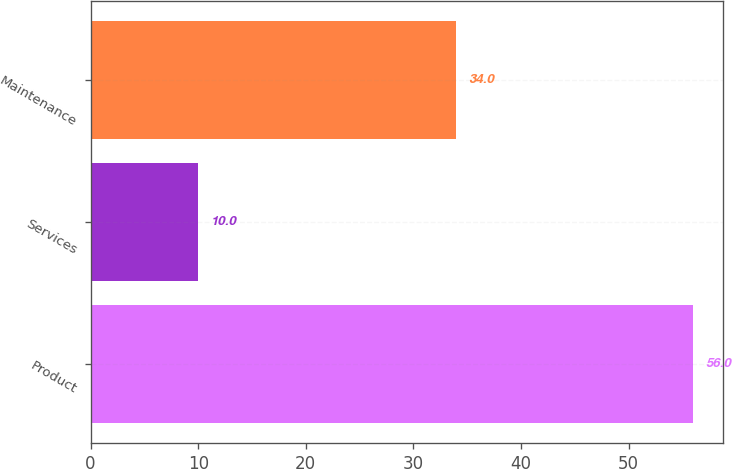<chart> <loc_0><loc_0><loc_500><loc_500><bar_chart><fcel>Product<fcel>Services<fcel>Maintenance<nl><fcel>56<fcel>10<fcel>34<nl></chart> 